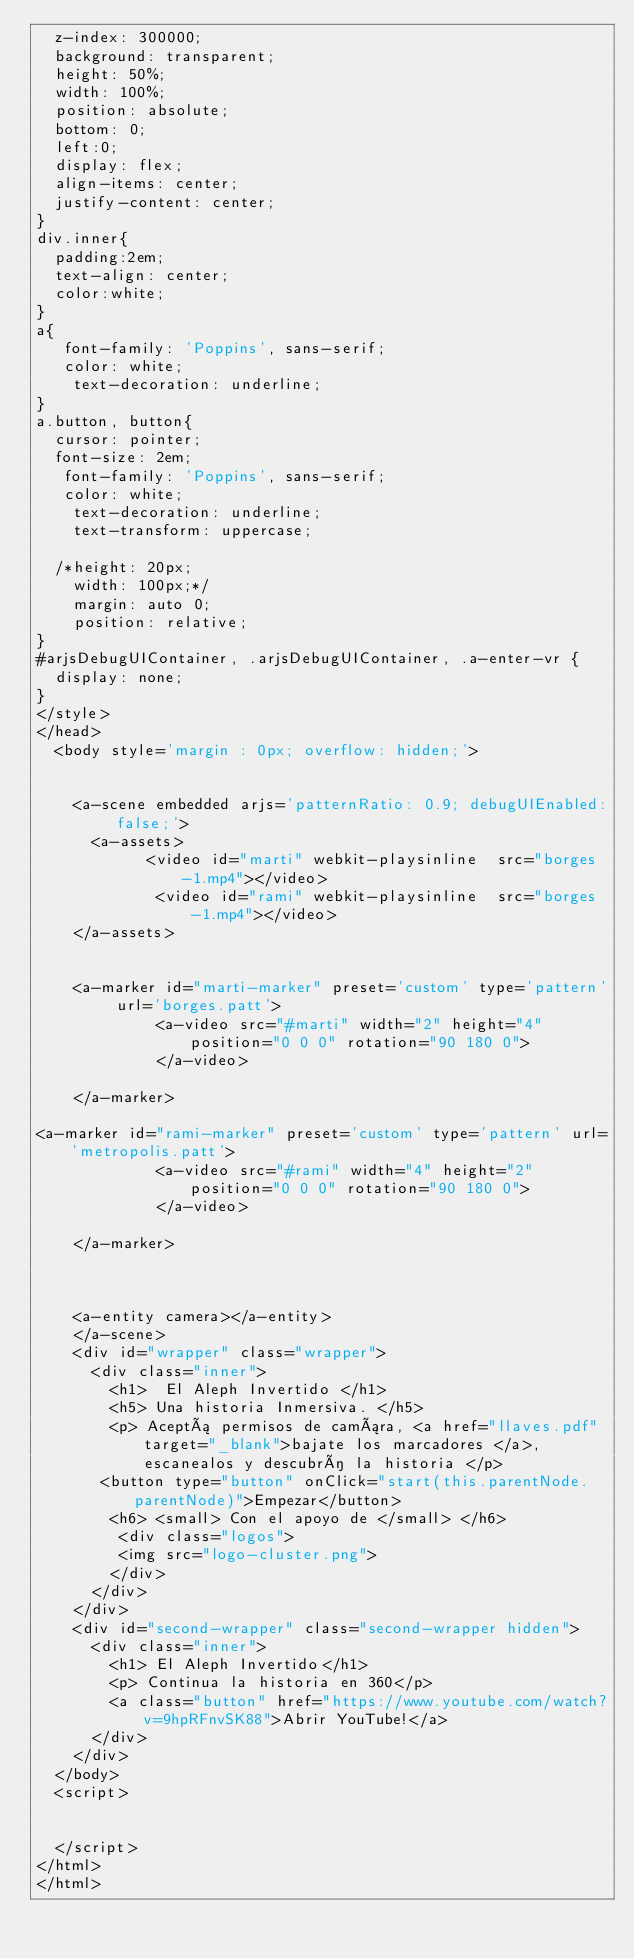<code> <loc_0><loc_0><loc_500><loc_500><_HTML_>  z-index: 300000;
  background: transparent;
  height: 50%;
  width: 100%;
  position: absolute;
  bottom: 0;
  left:0;
  display: flex;
  align-items: center;
  justify-content: center;
}
div.inner{
  padding:2em;
  text-align: center;
  color:white;
}
a{
   font-family: 'Poppins', sans-serif;
   color: white;
    text-decoration: underline;
}
a.button, button{
  cursor: pointer;
  font-size: 2em;
   font-family: 'Poppins', sans-serif;
   color: white;
    text-decoration: underline;
    text-transform: uppercase;

  /*height: 20px;
    width: 100px;*/
    margin: auto 0;
    position: relative;
}
#arjsDebugUIContainer, .arjsDebugUIContainer, .a-enter-vr {
  display: none;
}
</style>
</head>
  <body style='margin : 0px; overflow: hidden;'>
   

    <a-scene embedded arjs='patternRatio: 0.9; debugUIEnabled: false;'>
      <a-assets>
            <video id="marti" webkit-playsinline  src="borges-1.mp4"></video>
             <video id="rami" webkit-playsinline  src="borges-1.mp4"></video>
    </a-assets>  	
 
    
    <a-marker id="marti-marker" preset='custom' type='pattern' url='borges.patt'>
             <a-video src="#marti" width="2" height="4" position="0 0 0" rotation="90 180 0">
             </a-video>

    </a-marker>

<a-marker id="rami-marker" preset='custom' type='pattern' url='metropolis.patt'>
             <a-video src="#rami" width="4" height="2" position="0 0 0" rotation="90 180 0">
             </a-video>
             
    </a-marker>

   
    
  	<a-entity camera></a-entity>
    </a-scene>
    <div id="wrapper" class="wrapper">
      <div class="inner">
        <h1>  El Aleph Invertido </h1>
        <h5> Una historia Inmersiva. </h5>
        <p> Aceptá permisos de camára, <a href="llaves.pdf" target="_blank">bajate los marcadores </a>, escanealos y descubrí la historia </p>
       <button type="button" onClick="start(this.parentNode.parentNode)">Empezar</button>
        <h6> <small> Con el apoyo de </small> </h6>
         <div class="logos">
         <img src="logo-cluster.png">
        </div>
      </div>
    </div>
    <div id="second-wrapper" class="second-wrapper hidden">
      <div class="inner">
        <h1> El Aleph Invertido</h1>
        <p> Continua la historia en 360</p>
        <a class="button" href="https://www.youtube.com/watch?v=9hpRFnvSK88">Abrir YouTube!</a>
      </div>
    </div>
  </body>
  <script>
   

  </script>
</html>
</html></code> 